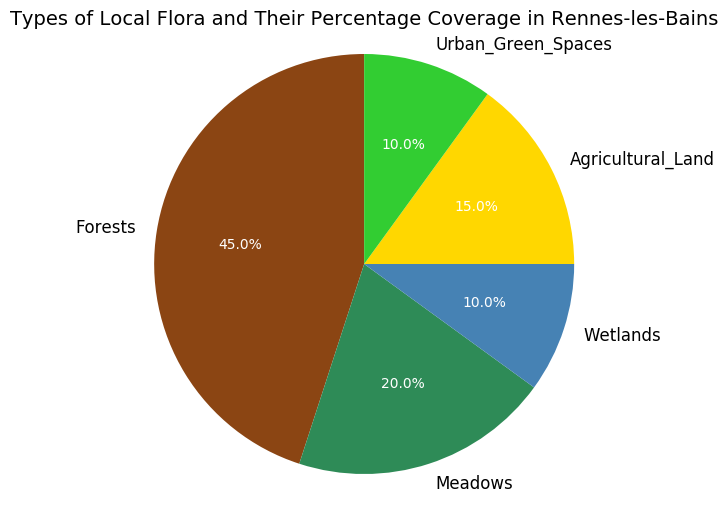Which type of flora has the largest percentage coverage? The pie chart shows that "Forests" have the largest slice, indicating the highest percentage coverage.
Answer: Forests How much more percentage coverage do forests have compared to meadows? Forests have 45% coverage, and meadows have 20%. Subtracting the two gives 45% - 20% = 25%.
Answer: 25% What is the combined percentage coverage of wetlands and urban green spaces? Wetlands have 10% and urban green spaces have 10%. Adding these together gives 10% + 10% = 20%.
Answer: 20% If agricultural land and meadows were combined into one category, what would their total percentage coverage be? Agricultural land has 15% and meadows have 20%. Adding these together gives 15% + 20% = 35%.
Answer: 35% Which type of flora has equal percentage coverage to urban green spaces? The pie chart shows that both wetlands and urban green spaces have 10% coverage each.
Answer: Wetlands Rank the types of local flora from highest to lowest coverage. By comparing the sizes of the slices in the pie chart: Forests (45%), Meadows (20%), Agricultural Land (15%), Wetlands and Urban Green Spaces (10% each).
Answer: Forests, Meadows, Agricultural Land, Wetlands, Urban Green Spaces Which type of flora has the second largest percentage coverage? From the pie chart, after forests (45%), meadows have the next largest slice with 20%.
Answer: Meadows Calculate the percentage coverage difference between the smallest and the largest flora types. The largest coverage is by forests at 45%, and the smallest is by both wetlands and urban green spaces at 10%. The difference is 45% - 10% = 35%.
Answer: 35% What percentage of the area is not covered by forests? Forests cover 45%, so the remaining area is 100% - 45% = 55%.
Answer: 55% 